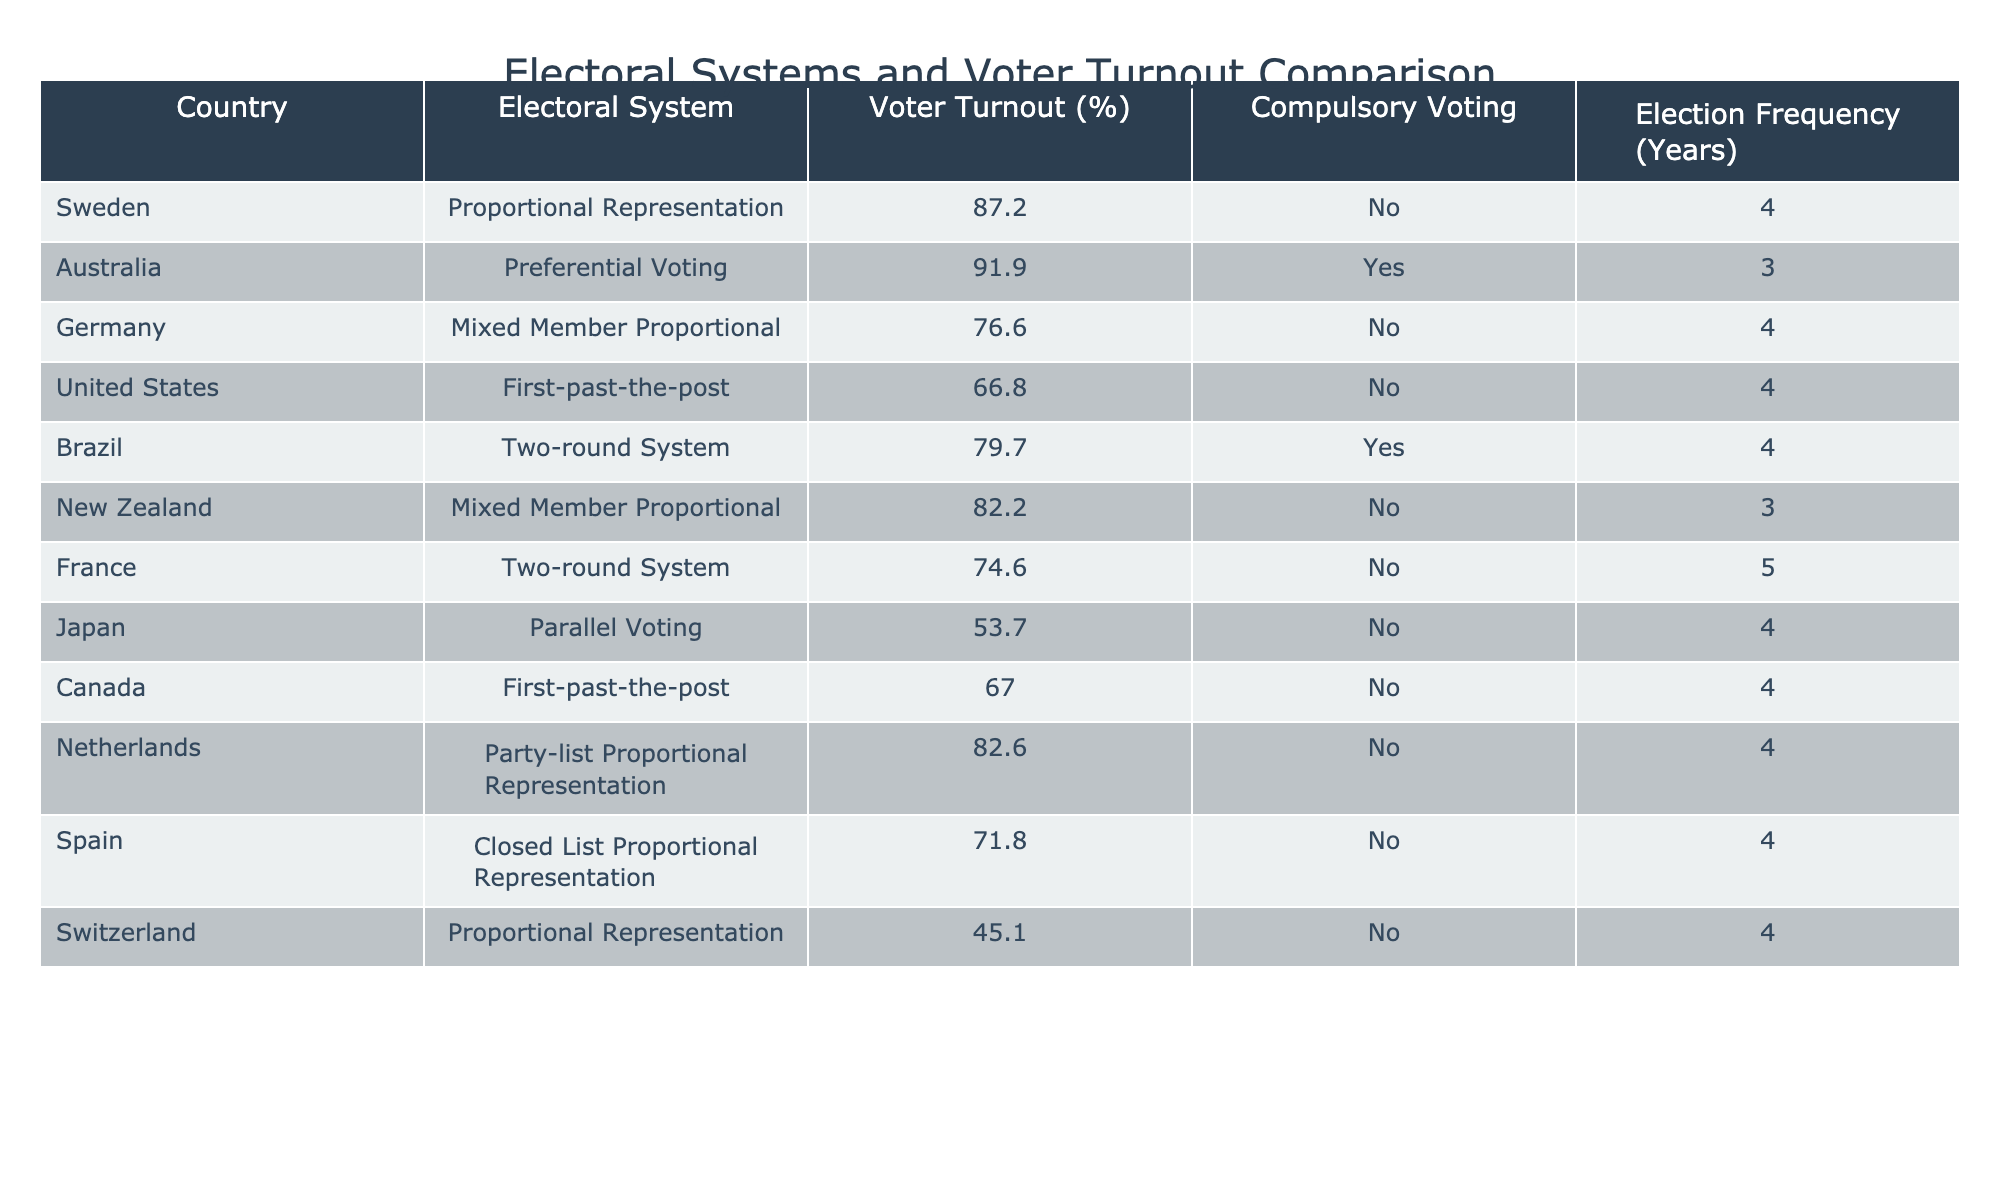What is the voter turnout percentage in Sweden? The voter turnout percentage for Sweden is explicitly mentioned in the table in the "Voter Turnout (%)" column, which shows it to be 87.2%
Answer: 87.2% Which countries have compulsory voting? By checking the "Compulsory Voting" column in the table, Australia and Brazil are the only countries marked as "Yes," meaning they have compulsory voting
Answer: Australia, Brazil What is the electoral system used in Germany? The "Electoral System" column for Germany indicates it uses a "Mixed Member Proportional" system
Answer: Mixed Member Proportional What is the average voter turnout of countries with compulsory voting? First, identify the voter turnout percentages for countries with compulsory voting, which are Australia (91.9) and Brazil (79.7). Then calculate the average: (91.9 + 79.7) / 2 = 85.8
Answer: 85.8 Is Japan's voter turnout higher than that of the United States? Japan has a voter turnout of 53.7%, whereas the United States has a turnout of 66.8%. Comparing these two figures, 53.7% is less than 66.8%, thus Japan's turnout is not higher
Answer: No What is the relationship between the electoral system and voter turnout in the countries listed? To analyze this, one might look for patterns where electoral systems align with either high or low voter turnout. By reviewing the "Voter Turnout (%)" in conjunction with the "Electoral System," it appears that countries with preferential or proportional systems tend to have higher turnout compared to first-past-the-post systems like in the United States and Canada. This usually indicates that more representative systems might foster higher voter participation
Answer: More representative systems may lead to higher turnout Which electoral system is associated with the lowest voter turnout percentage? The table shows Switzerland, with a voter turnout of 45.1%, as the lowest percentage among the provided countries. This information is found under the "Voter Turnout (%)" column
Answer: Proportional Representation What is the election frequency for countries utilizing first-past-the-post systems? The election frequency for the United States and Canada, which both utilize this system, can be found under the "Election Frequency (Years)" column: both have elections every 4 years. Therefore, the answer refers to the frequency as 4
Answer: 4 